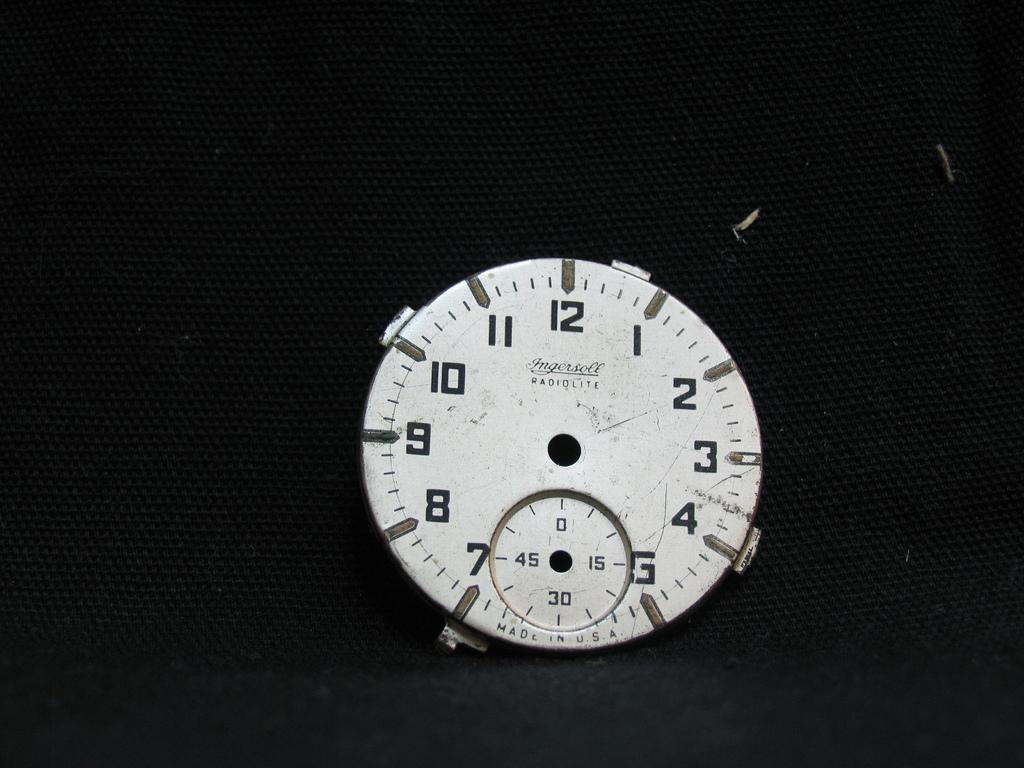Provide a one-sentence caption for the provided image. The face of a time piece with Ingersoll RADIOLITE and Made in U.S.A. is shown on a black background. 